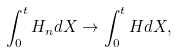Convert formula to latex. <formula><loc_0><loc_0><loc_500><loc_500>\int _ { 0 } ^ { t } H _ { n } d X \to \int _ { 0 } ^ { t } H d X ,</formula> 